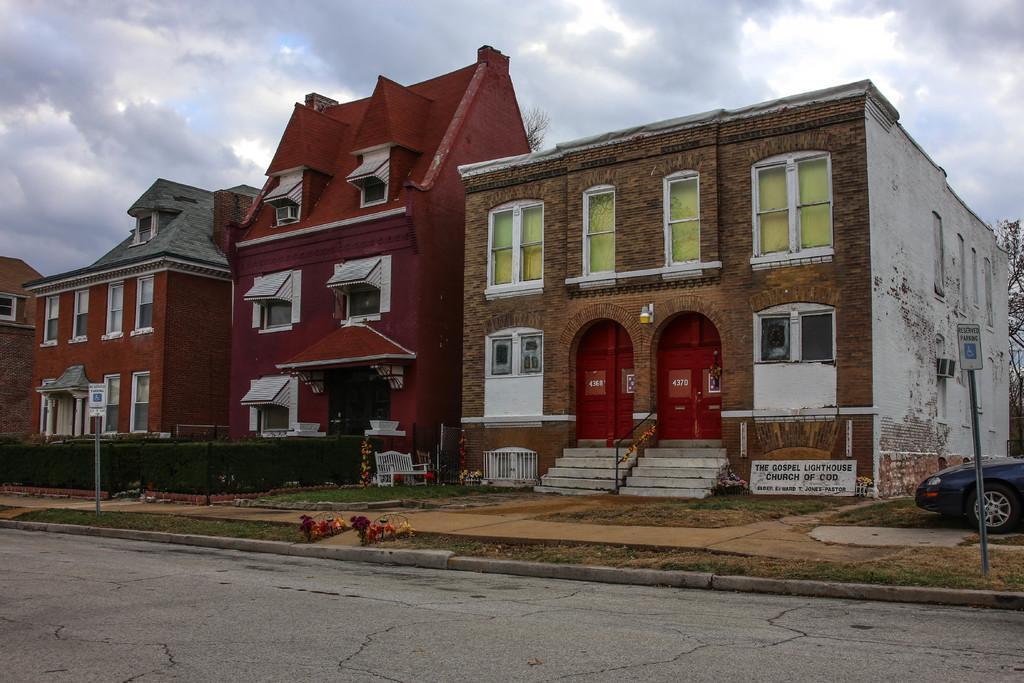Describe this image in one or two sentences. In this image we can see a few buildings, there are some windows, doors, poles, boards, plants, trees, staircase, bench and a vehicle, in the background we can see the sky with clouds. 